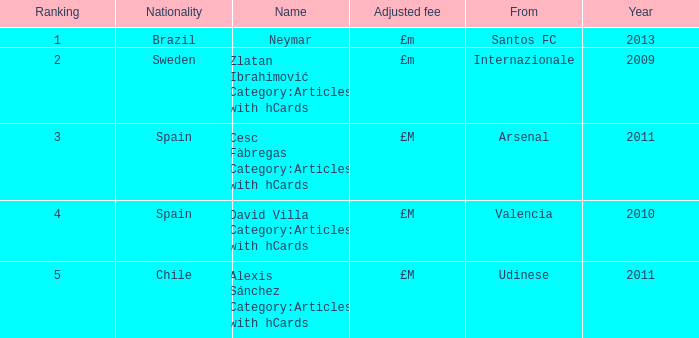What is the name of the player from Spain with a rank lower than 3? David Villa Category:Articles with hCards. 